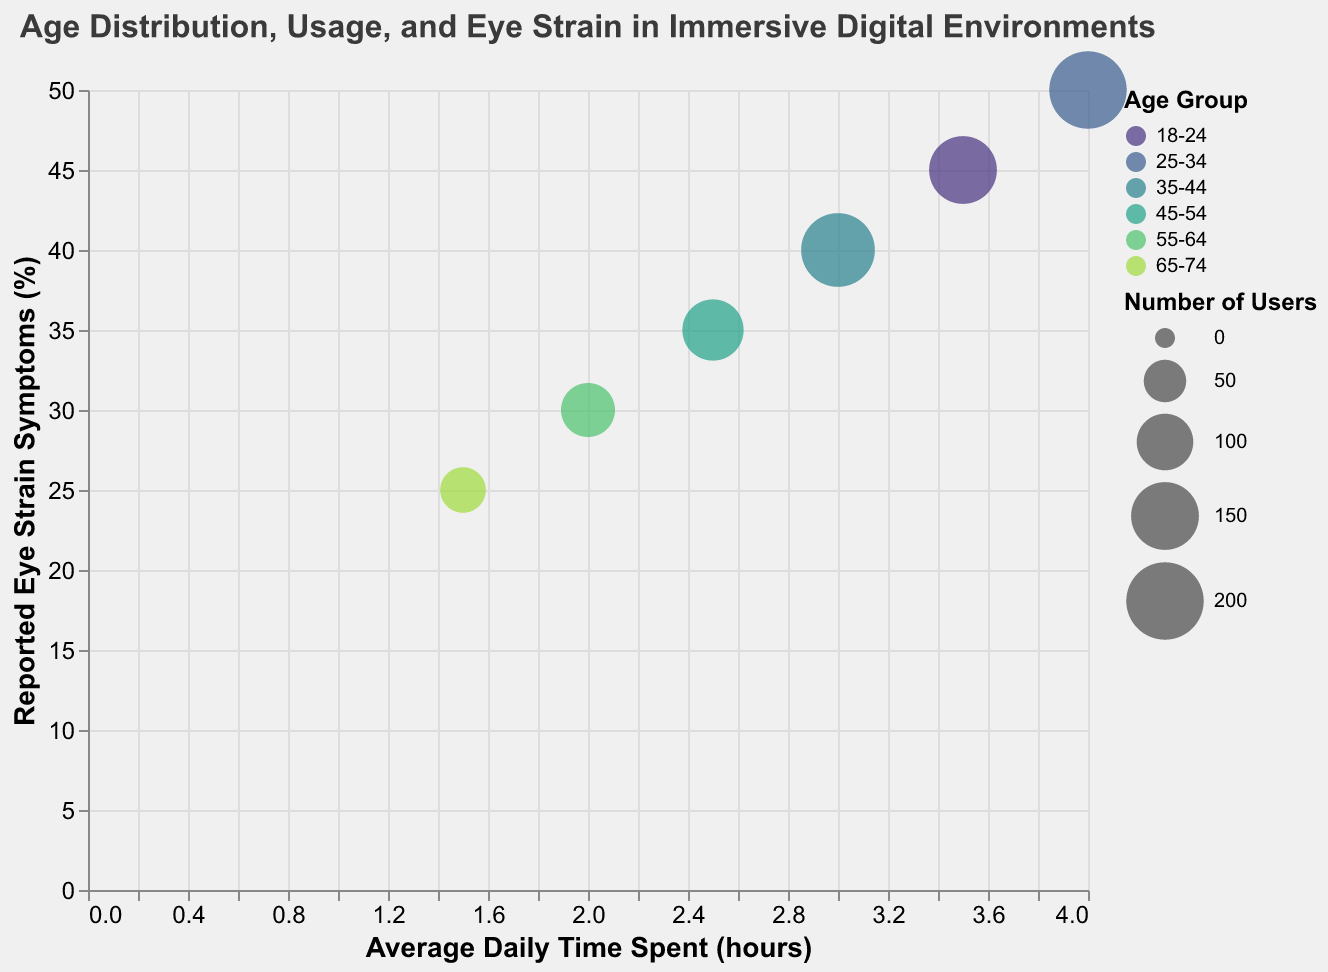How many age groups are represented in the chart? The chart shows data points for each age group represented by different colors. By counting the distinct colors (or data points) on the chart, we can identify the number of age groups.
Answer: 6 Which age group has the highest reported eye strain symptoms percentage? The reported eye strain symptoms are plotted on the y-axis. By finding the highest point on the y-axis, we can determine which age group it represents, and hence find the age group with the highest eye strain symptoms.
Answer: 25-34 For the age group 35-44, what is the average daily time spent in immersive digital environments? Each bubble is placed horizontally according to the average daily time spent. Finding the bubble that corresponds to the age group 35-44 and looking at its x-axis value will give the average daily time spent.
Answer: 3 hours Among the age groups 18-24 and 45-54, which one reports a lower percentage of eye strain symptoms? By comparing the y-axis values for the age groups 18-24 and 45-54, we can determine which one reports a lower percentage of eye strain symptoms.
Answer: 45-54 What is the difference in the number of users between the age groups 25-34 and 65-74? The size of the bubble represents the number of users. To find the difference, note the sizes for the age groups 25-34 and 65-74, then subtract the smaller number from the larger one.
Answer: 140 Which age group spends the least average daily time in immersive digital environments? The x-axis represents the average daily time spent. The bubble furthest to the left represents the age group that spends the least time.
Answer: 65-74 Is there a correlation between average daily time spent and reported eye strain symptoms among the age groups? By observing the general trend of data points across the x-axis (average daily time spent) and y-axis (reported eye strain symptoms), we can identify if an upward or downward trend exists, indicating correlation.
Answer: Yes, there is a positive correlation What is the percentage difference in reported eye strain symptoms between the age groups 25-34 and 55-64? By identifying the y-axis positions of the age groups 25-34 and 55-64, and calculating the percentage difference between these values ((50 - 30) / 30) * 100.
Answer: 66.67% Which age group has the smallest bubble size, and what does it represent? The size of the bubble indicates the number of users. The smallest bubble size will represent the age group with the lowest number of users.
Answer: 65-74, representing 60 users What is the overall trend in reported eye strain symptoms as the average daily time spent increases? By observing the alignment of bubbles from left to right, we can determine if the percentage of reported eye strain symptoms generally increases, decreases, or remains constant with increasing average daily time spent.
Answer: Increases 